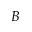Convert formula to latex. <formula><loc_0><loc_0><loc_500><loc_500>B</formula> 